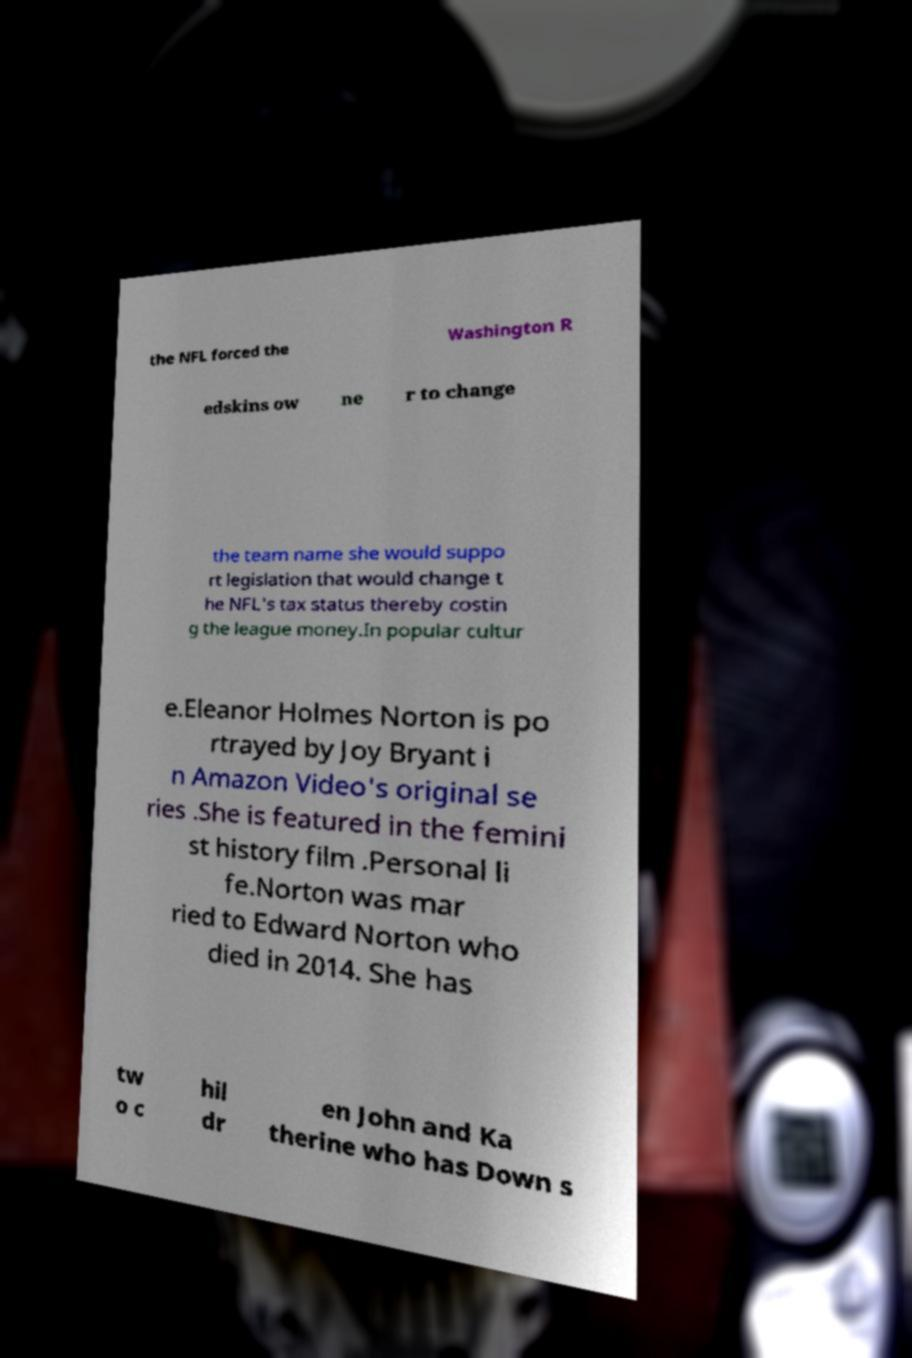Can you accurately transcribe the text from the provided image for me? the NFL forced the Washington R edskins ow ne r to change the team name she would suppo rt legislation that would change t he NFL's tax status thereby costin g the league money.In popular cultur e.Eleanor Holmes Norton is po rtrayed by Joy Bryant i n Amazon Video's original se ries .She is featured in the femini st history film .Personal li fe.Norton was mar ried to Edward Norton who died in 2014. She has tw o c hil dr en John and Ka therine who has Down s 